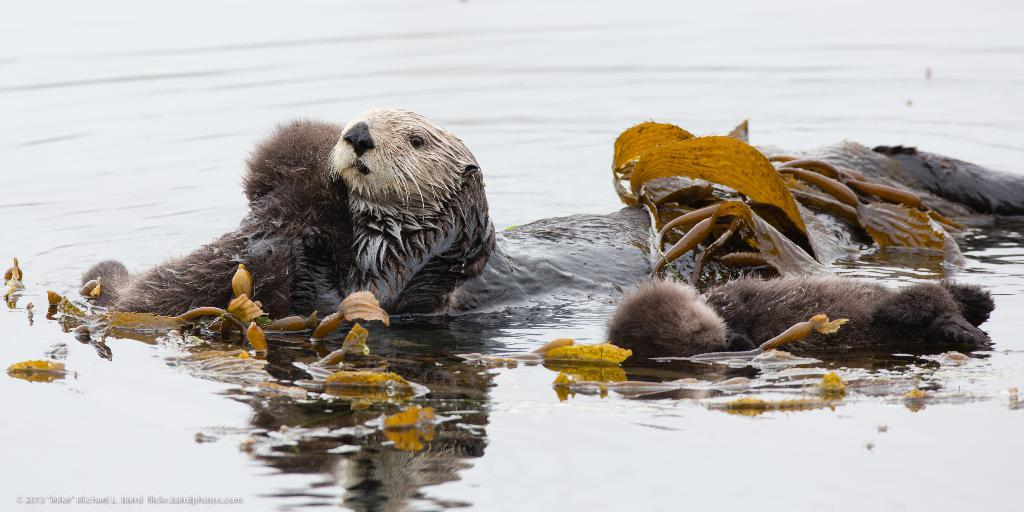What type of animals can be seen in the image? There are animals in the image. Where are the animals located? The animals are on the water. What else can be seen on the water in the image? There are leaves on the water in the image. What type of pollution can be seen in the image? There is no pollution visible in the image; it features animals and leaves on the water. Can you locate the nearest coffee shop on the map in the image? There is no map present in the image. 